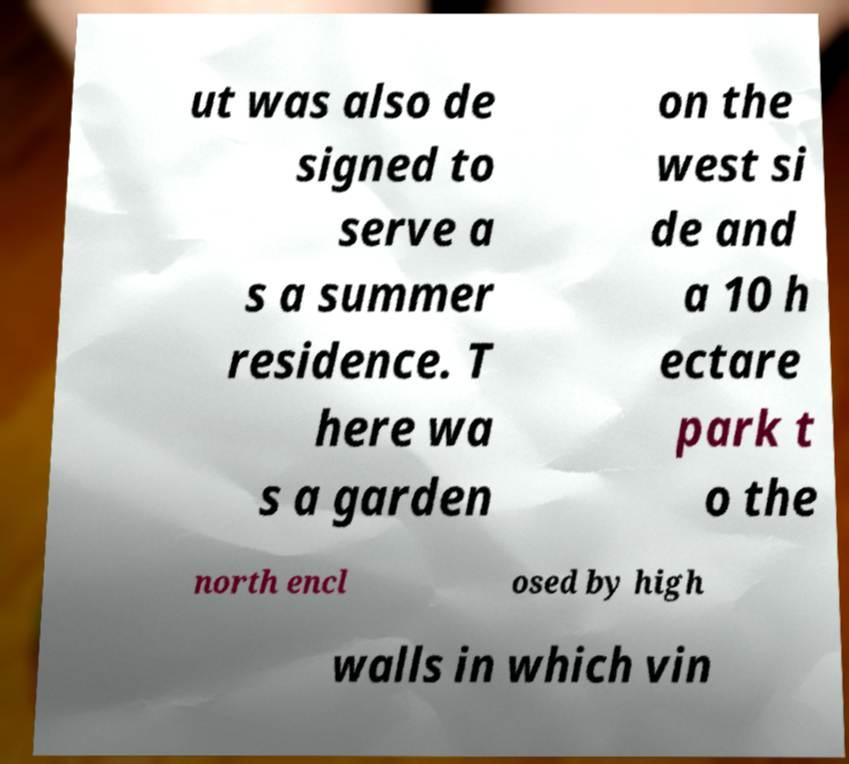Can you read and provide the text displayed in the image?This photo seems to have some interesting text. Can you extract and type it out for me? ut was also de signed to serve a s a summer residence. T here wa s a garden on the west si de and a 10 h ectare park t o the north encl osed by high walls in which vin 